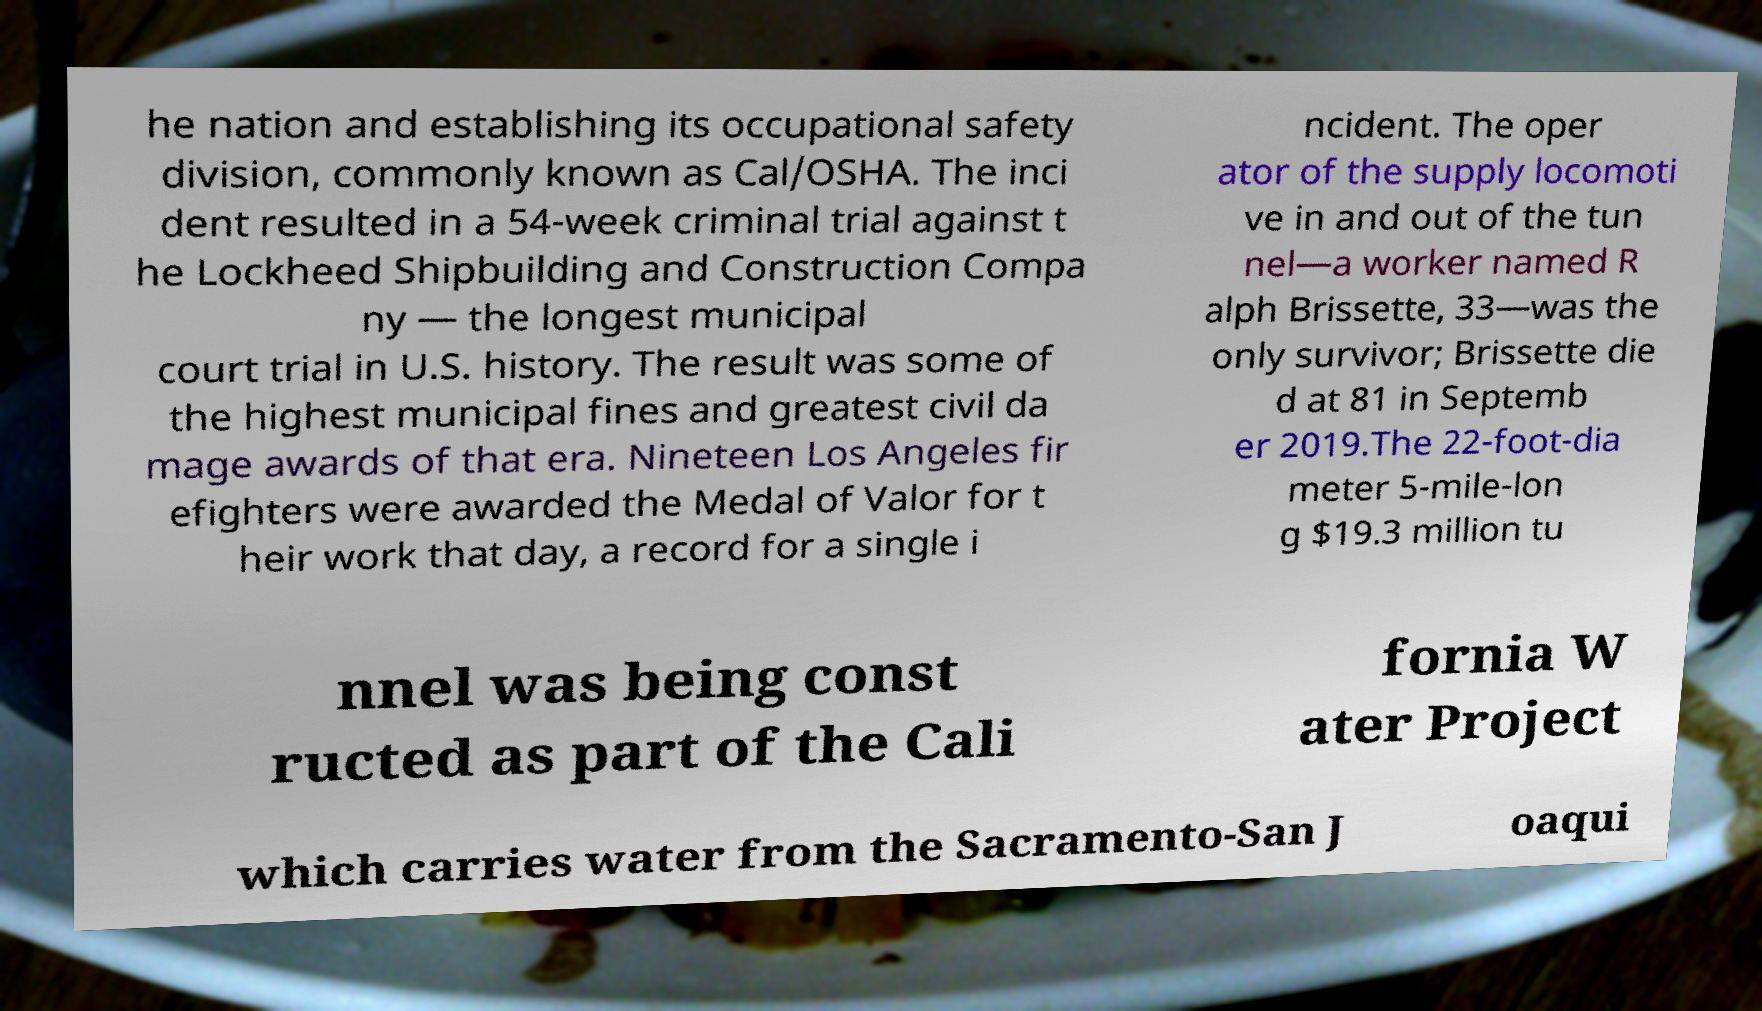For documentation purposes, I need the text within this image transcribed. Could you provide that? he nation and establishing its occupational safety division, commonly known as Cal/OSHA. The inci dent resulted in a 54-week criminal trial against t he Lockheed Shipbuilding and Construction Compa ny — the longest municipal court trial in U.S. history. The result was some of the highest municipal fines and greatest civil da mage awards of that era. Nineteen Los Angeles fir efighters were awarded the Medal of Valor for t heir work that day, a record for a single i ncident. The oper ator of the supply locomoti ve in and out of the tun nel—a worker named R alph Brissette, 33—was the only survivor; Brissette die d at 81 in Septemb er 2019.The 22-foot-dia meter 5-mile-lon g $19.3 million tu nnel was being const ructed as part of the Cali fornia W ater Project which carries water from the Sacramento-San J oaqui 